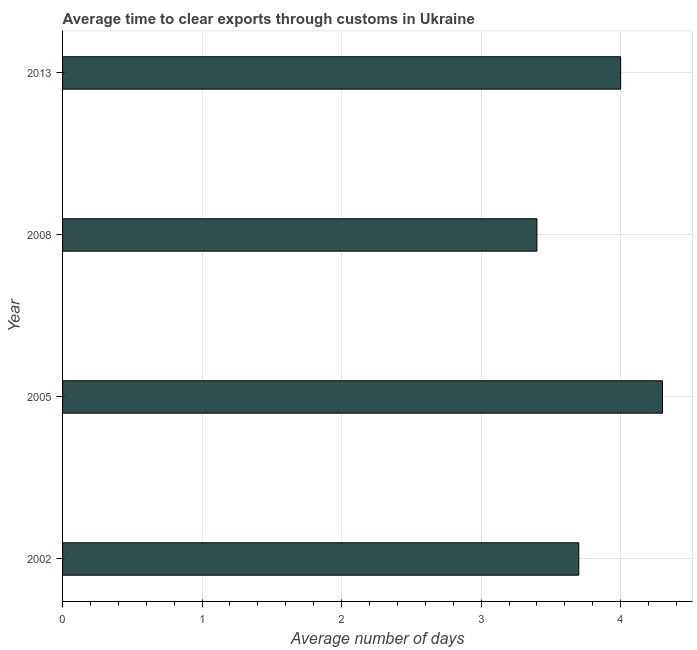Does the graph contain any zero values?
Provide a succinct answer. No. Does the graph contain grids?
Your response must be concise. Yes. What is the title of the graph?
Keep it short and to the point. Average time to clear exports through customs in Ukraine. What is the label or title of the X-axis?
Your answer should be compact. Average number of days. What is the time to clear exports through customs in 2013?
Your answer should be compact. 4. In which year was the time to clear exports through customs minimum?
Your answer should be very brief. 2008. What is the average time to clear exports through customs per year?
Your answer should be compact. 3.85. What is the median time to clear exports through customs?
Your answer should be compact. 3.85. What is the ratio of the time to clear exports through customs in 2002 to that in 2005?
Keep it short and to the point. 0.86. Is the time to clear exports through customs in 2002 less than that in 2008?
Provide a succinct answer. No. What is the difference between the highest and the second highest time to clear exports through customs?
Provide a short and direct response. 0.3. Is the sum of the time to clear exports through customs in 2005 and 2013 greater than the maximum time to clear exports through customs across all years?
Your answer should be very brief. Yes. What is the difference between the highest and the lowest time to clear exports through customs?
Make the answer very short. 0.9. Are all the bars in the graph horizontal?
Keep it short and to the point. Yes. How many years are there in the graph?
Ensure brevity in your answer.  4. What is the difference between two consecutive major ticks on the X-axis?
Ensure brevity in your answer.  1. What is the Average number of days in 2002?
Provide a short and direct response. 3.7. What is the Average number of days of 2013?
Offer a very short reply. 4. What is the difference between the Average number of days in 2002 and 2005?
Offer a terse response. -0.6. What is the difference between the Average number of days in 2002 and 2008?
Provide a short and direct response. 0.3. What is the difference between the Average number of days in 2002 and 2013?
Your response must be concise. -0.3. What is the ratio of the Average number of days in 2002 to that in 2005?
Your response must be concise. 0.86. What is the ratio of the Average number of days in 2002 to that in 2008?
Offer a very short reply. 1.09. What is the ratio of the Average number of days in 2002 to that in 2013?
Your answer should be very brief. 0.93. What is the ratio of the Average number of days in 2005 to that in 2008?
Your answer should be compact. 1.26. What is the ratio of the Average number of days in 2005 to that in 2013?
Offer a terse response. 1.07. What is the ratio of the Average number of days in 2008 to that in 2013?
Keep it short and to the point. 0.85. 